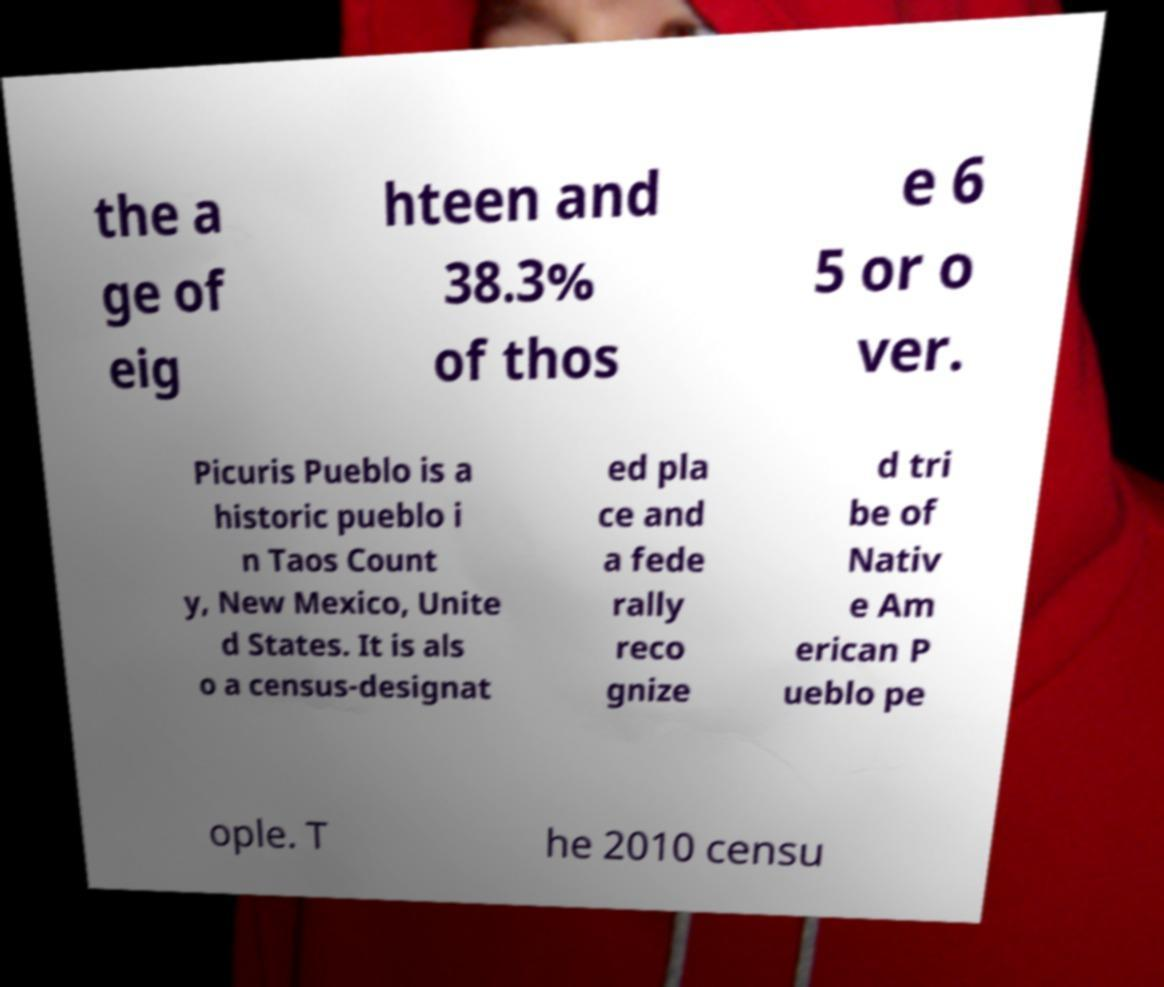What messages or text are displayed in this image? I need them in a readable, typed format. the a ge of eig hteen and 38.3% of thos e 6 5 or o ver. Picuris Pueblo is a historic pueblo i n Taos Count y, New Mexico, Unite d States. It is als o a census-designat ed pla ce and a fede rally reco gnize d tri be of Nativ e Am erican P ueblo pe ople. T he 2010 censu 